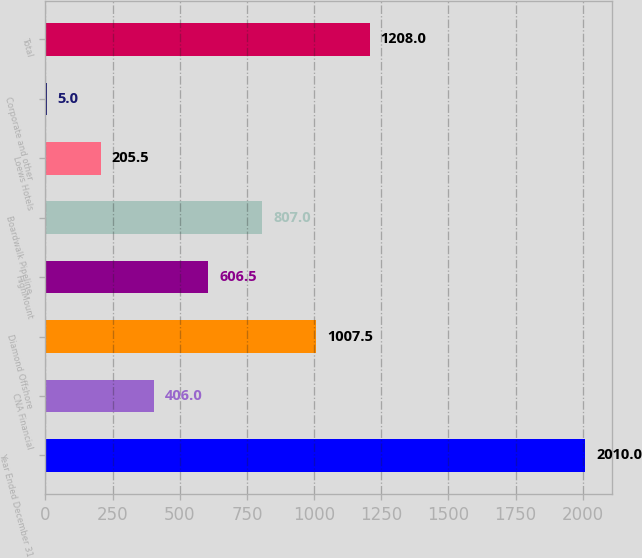Convert chart to OTSL. <chart><loc_0><loc_0><loc_500><loc_500><bar_chart><fcel>Year Ended December 31<fcel>CNA Financial<fcel>Diamond Offshore<fcel>HighMount<fcel>Boardwalk Pipeline<fcel>Loews Hotels<fcel>Corporate and other<fcel>Total<nl><fcel>2010<fcel>406<fcel>1007.5<fcel>606.5<fcel>807<fcel>205.5<fcel>5<fcel>1208<nl></chart> 